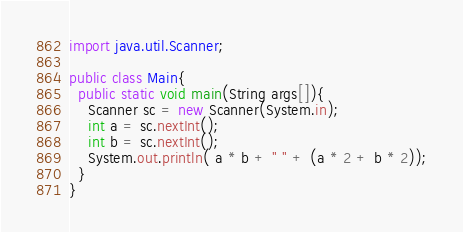<code> <loc_0><loc_0><loc_500><loc_500><_Java_>import java.util.Scanner;

public class Main{
  public static void main(String args[]){
    Scanner sc = new Scanner(System.in);
    int a = sc.nextInt();
    int b = sc.nextInt();
    System.out.println( a * b + " " + (a * 2 + b * 2));
  }
}
</code> 